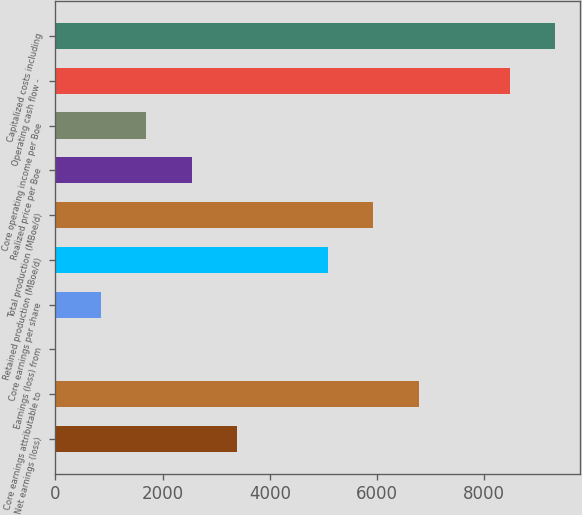Convert chart. <chart><loc_0><loc_0><loc_500><loc_500><bar_chart><fcel>Net earnings (loss)<fcel>Core earnings attributable to<fcel>Earnings (loss) from<fcel>Core earnings per share<fcel>Retained production (MBoe/d)<fcel>Total production (MBoe/d)<fcel>Realized price per Boe<fcel>Core operating income per Boe<fcel>Operating cash flow -<fcel>Capitalized costs including<nl><fcel>3389.87<fcel>6779.27<fcel>0.47<fcel>847.82<fcel>5084.57<fcel>5931.92<fcel>2542.52<fcel>1695.17<fcel>8473.97<fcel>9321.32<nl></chart> 